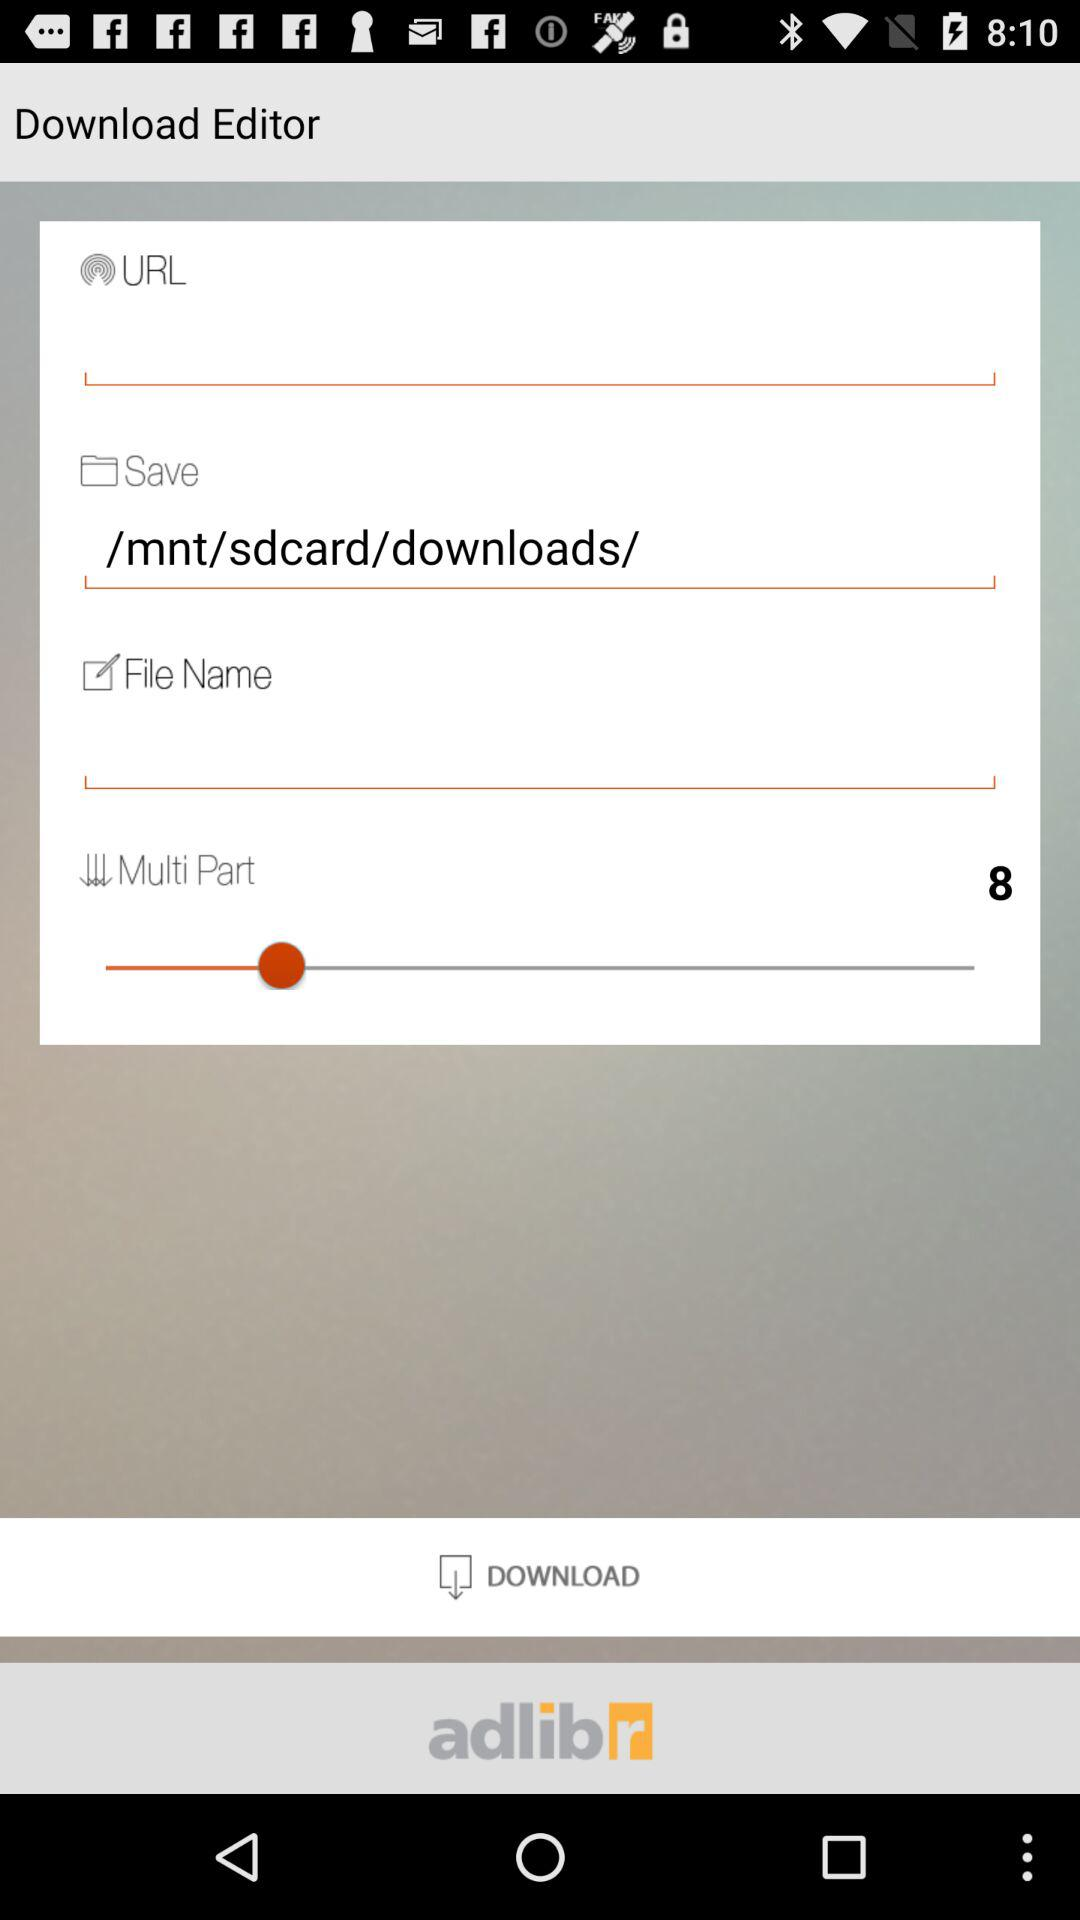How many text inputs are in the Download Editor interface?
Answer the question using a single word or phrase. 3 